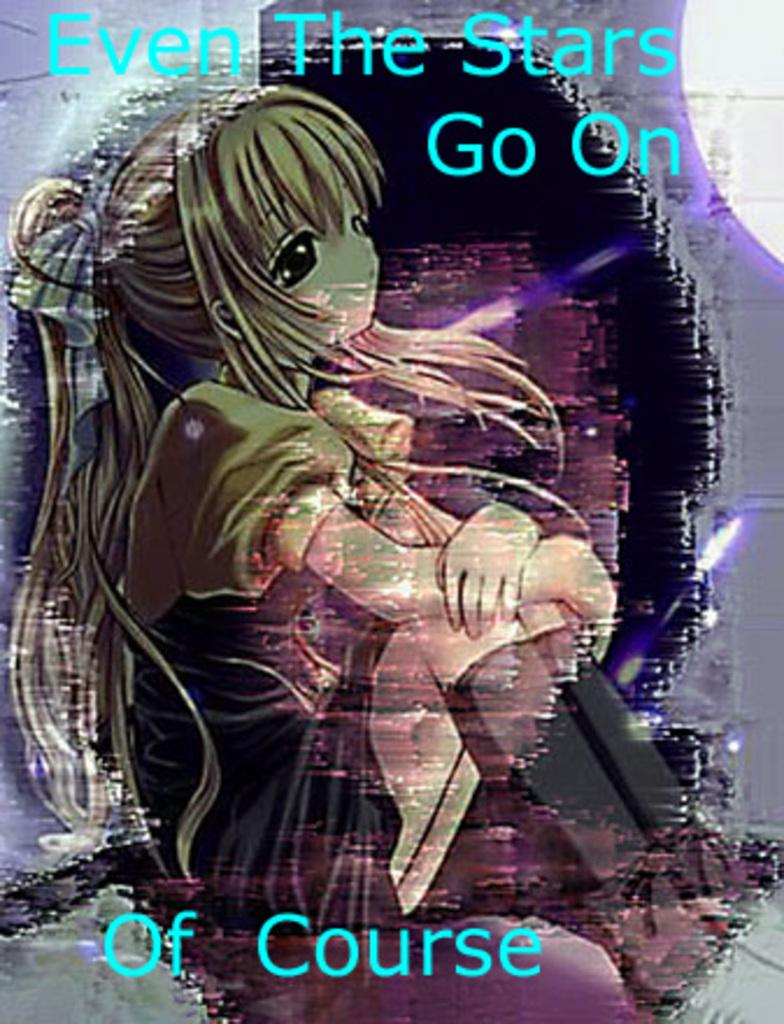What is the main subject of the image? There is a depiction of a person in the image. Are there any words or letters in the image? Yes, there is some text in the image. How many trees are visible in the image? There are no trees visible in the image; it only features a depiction of a person and some text. What type of bomb is being used by the person in the image? There is no bomb present in the image; it only features a depiction of a person and some text. 